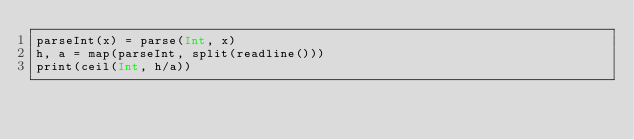<code> <loc_0><loc_0><loc_500><loc_500><_Julia_>parseInt(x) = parse(Int, x)
h, a = map(parseInt, split(readline()))
print(ceil(Int, h/a))</code> 